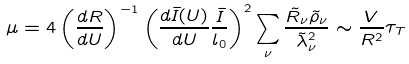<formula> <loc_0><loc_0><loc_500><loc_500>\mu = 4 \left ( \frac { d R } { d U } \right ) ^ { - 1 } \left ( \frac { d \bar { I } ( U ) } { d U } \frac { \bar { I } } { l _ { 0 } } \right ) ^ { 2 } \sum _ { \nu } \frac { \tilde { R } _ { \nu } \tilde { \rho } _ { \nu } } { \tilde { \lambda } _ { \nu } ^ { 2 } } \sim \frac { V } { R ^ { 2 } } \tau _ { T }</formula> 